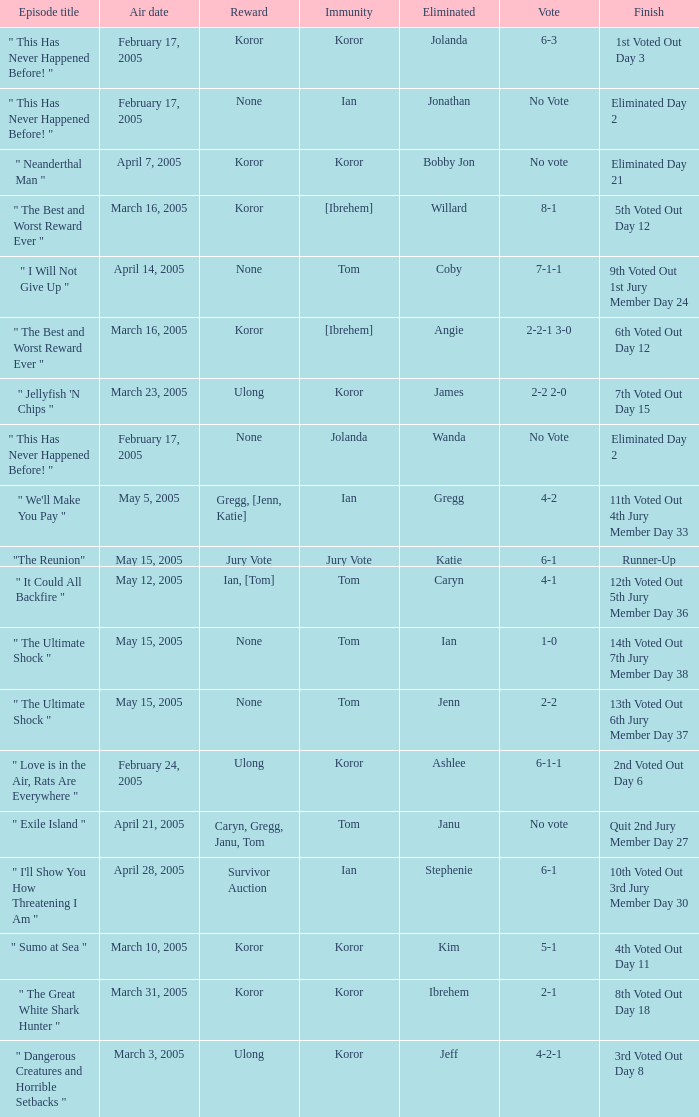What is the name of the episode in which Jenn is eliminated? " The Ultimate Shock ". 